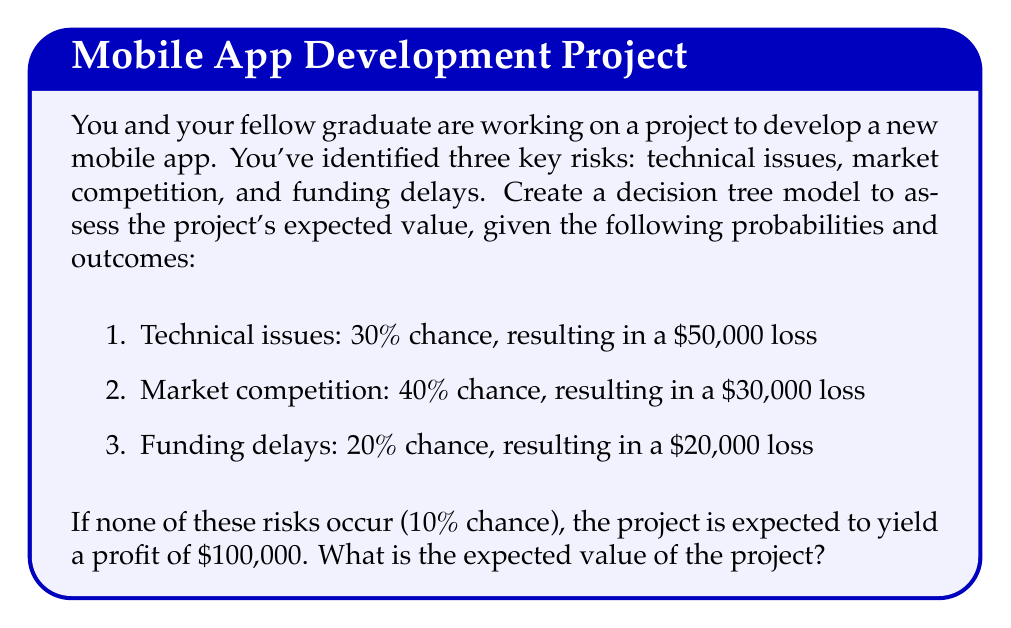Provide a solution to this math problem. Let's approach this step-by-step using a decision tree model:

1. First, we'll create a decision tree with branches for each possible outcome:

[asy]
unitsize(1cm);

draw((0,0)--(1,1), arrow=Arrow);
draw((0,0)--(1,-1), arrow=Arrow);
draw((1,1)--(2,2), arrow=Arrow);
draw((1,1)--(2,0), arrow=Arrow);
draw((1,-1)--(2,-2), arrow=Arrow);
draw((1,-1)--(2,-4), arrow=Arrow);

label("Start", (0,0), W);
label("Risk occurs (90%)", (1,1), N);
label("No risk (10%)", (1,-1), S);
label("Tech issues (30%)", (2,2), NE);
label("Market comp (40%)", (2,0), E);
label("Funding delays (20%)", (2,-2), E);
label("Profit", (2,-4), SE);
[/asy]

2. Now, let's calculate the expected value for each branch:

   a. Technical issues: $0.30 \times (-\$50,000) = -\$15,000$
   b. Market competition: $0.40 \times (-\$30,000) = -\$12,000$
   c. Funding delays: $0.20 \times (-\$20,000) = -\$4,000$
   d. No risks (profit): $0.10 \times \$100,000 = \$10,000$

3. The expected value of the project is the sum of these outcomes:

   $$ EV = -\$15,000 + (-\$12,000) + (-\$4,000) + \$10,000 $$

4. Simplifying:

   $$ EV = -\$21,000 $$

Thus, the expected value of the project, considering all risks and potential profit, is -$21,000.
Answer: The expected value of the project is -$21,000. 